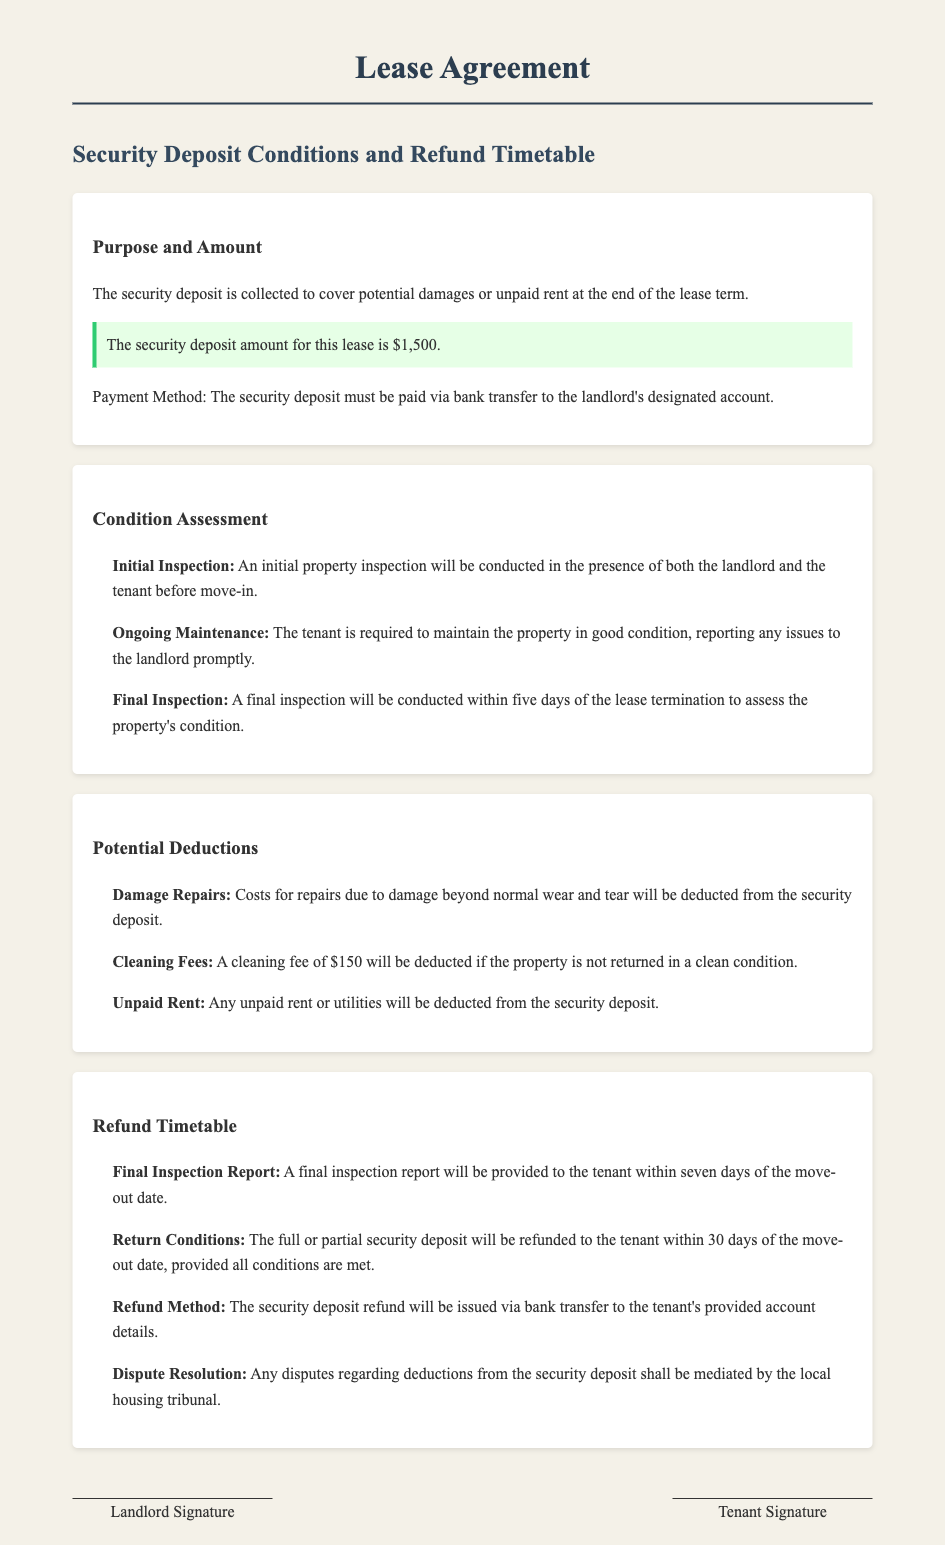What is the purpose of the security deposit? The purpose of the security deposit is to cover potential damages or unpaid rent at the end of the lease term.
Answer: To cover potential damages or unpaid rent What is the amount of the security deposit? The document specifies the exact figure for the security deposit.
Answer: $1,500 What is the method of payment for the security deposit? The document states how the security deposit must be paid.
Answer: Bank transfer When will the final inspection be conducted? The final inspection timing is stated based on the lease termination.
Answer: Within five days of the lease termination How much will be deducted for cleaning fees? The document lists specific fees associated with property condition.
Answer: $150 What will the tenant receive within seven days of the move-out date? This information pertains to the reporting process after tenant move-out.
Answer: Final inspection report What is the timeline for the security deposit refund? The document outlines the conditions for the refund timeline.
Answer: Within 30 days of the move-out date Who mediates disputes regarding deposit deductions? The document indicates the authority for resolving disputes related to the security deposit.
Answer: Local housing tribunal 